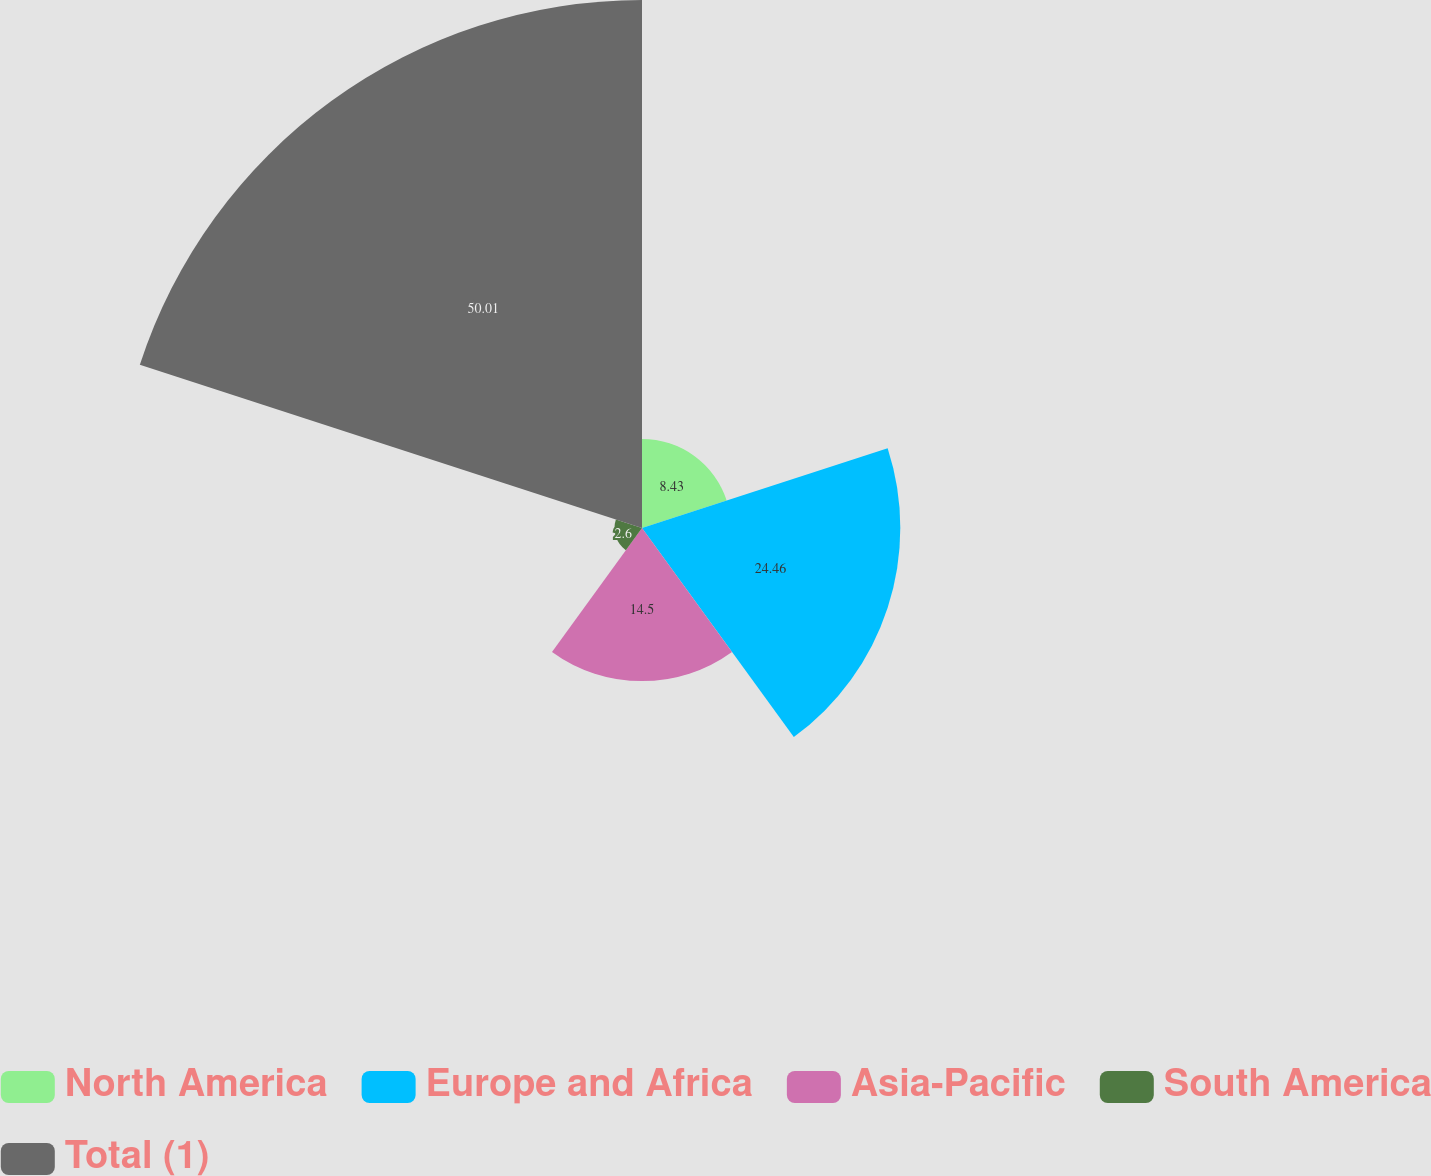Convert chart to OTSL. <chart><loc_0><loc_0><loc_500><loc_500><pie_chart><fcel>North America<fcel>Europe and Africa<fcel>Asia-Pacific<fcel>South America<fcel>Total (1)<nl><fcel>8.43%<fcel>24.46%<fcel>14.5%<fcel>2.6%<fcel>50.0%<nl></chart> 